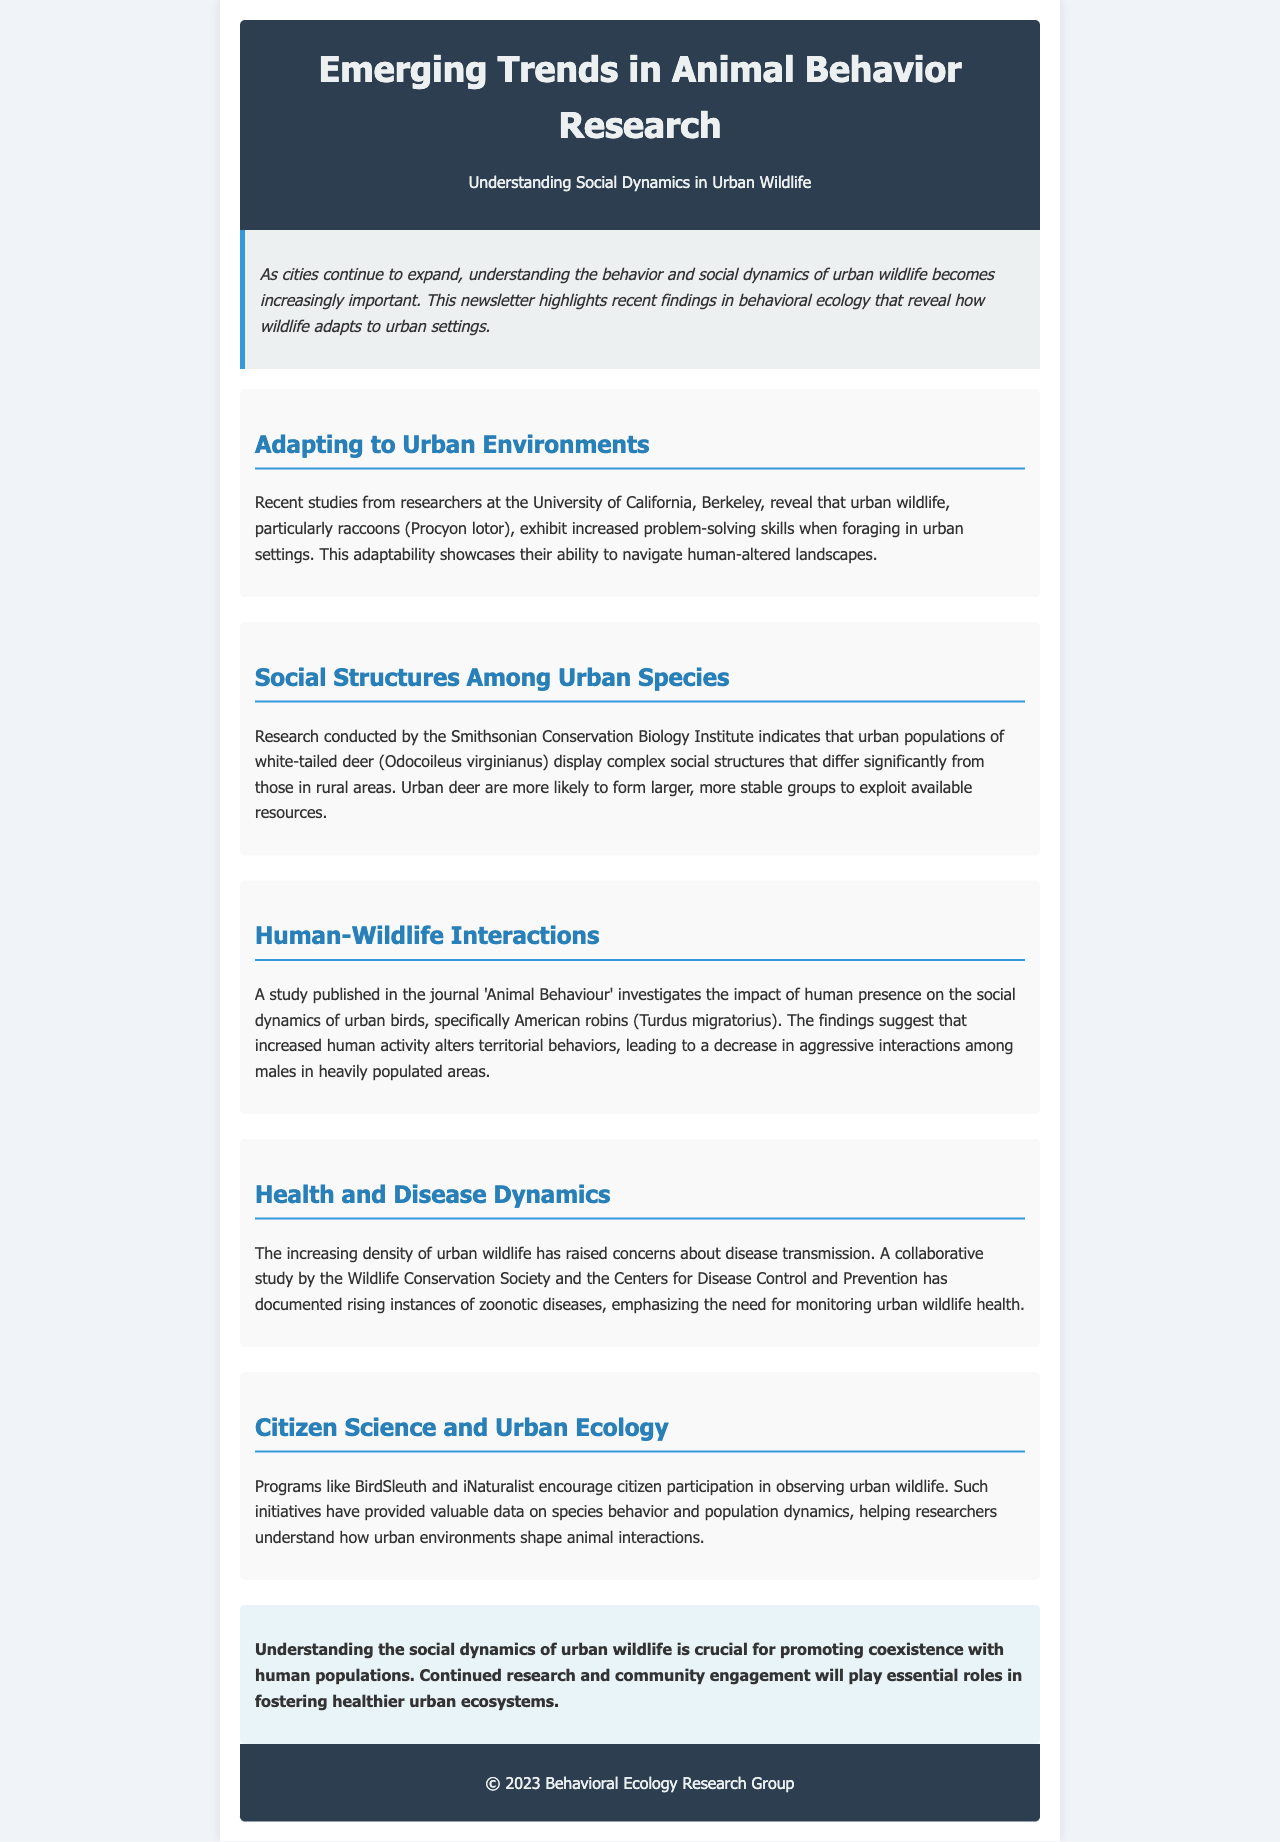What species exhibited increased problem-solving skills in urban settings? The document mentions that raccoons (Procyon lotor) exhibit increased problem-solving skills when foraging in urban environments.
Answer: raccoons (Procyon lotor) Which institute conducted research on urban populations of white-tailed deer? According to the document, the Smithsonian Conservation Biology Institute conducted research on urban populations of white-tailed deer.
Answer: Smithsonian Conservation Biology Institute What impact does increased human activity have on territorial behaviors of American robins? The findings suggest that increased human activity alters territorial behaviors, leading to a decrease in aggressive interactions among males.
Answer: decrease in aggressive interactions What disease-related concern is associated with increasing density of urban wildlife? The document highlights concerns about disease transmission due to the increasing density of urban wildlife.
Answer: disease transmission What role do citizen science programs play in urban ecology? Programs like BirdSleuth and iNaturalist encourage citizen participation, providing valuable data on species behavior and population dynamics.
Answer: valuable data on species behavior and population dynamics 